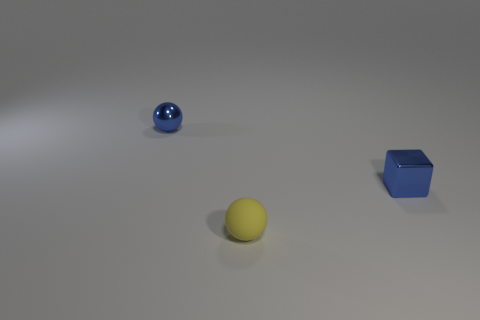Subtract all yellow balls. How many balls are left? 1 Subtract all balls. How many objects are left? 1 Subtract all blue cubes. How many yellow balls are left? 1 Add 3 small blue metallic blocks. How many objects exist? 6 Subtract 0 gray cubes. How many objects are left? 3 Subtract all gray balls. Subtract all green cubes. How many balls are left? 2 Subtract all small yellow cylinders. Subtract all metal cubes. How many objects are left? 2 Add 2 small rubber objects. How many small rubber objects are left? 3 Add 1 large green objects. How many large green objects exist? 1 